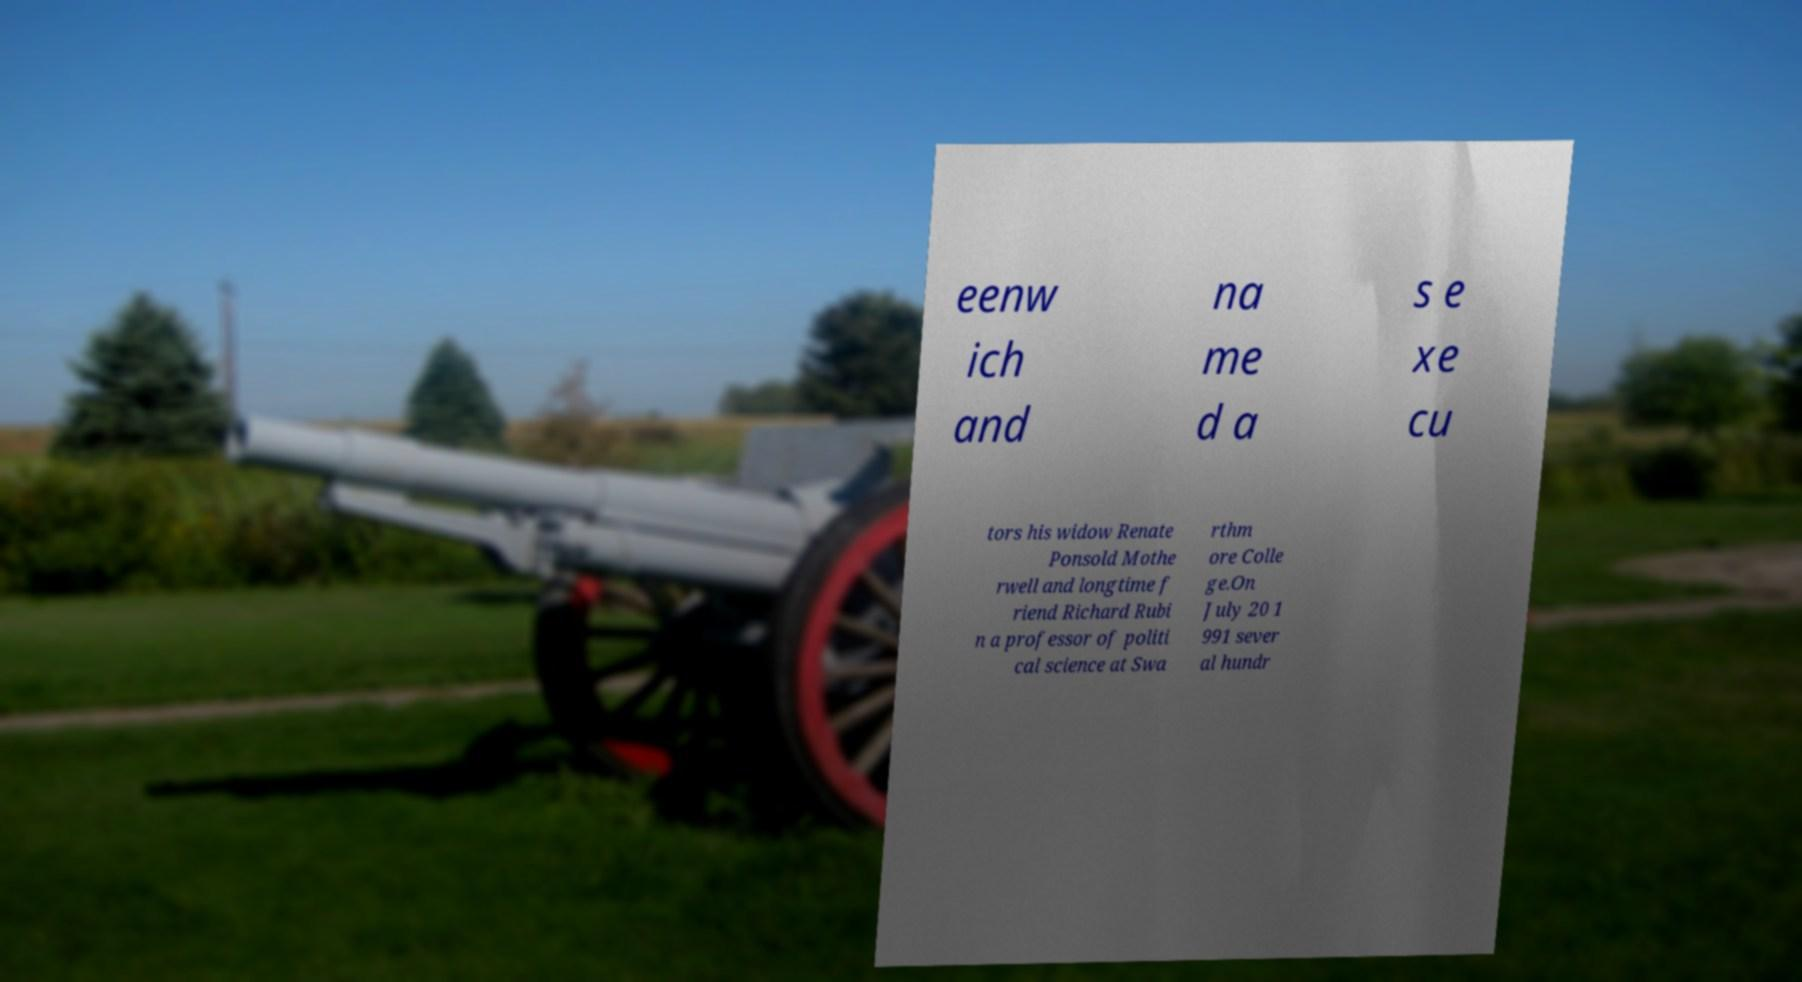There's text embedded in this image that I need extracted. Can you transcribe it verbatim? eenw ich and na me d a s e xe cu tors his widow Renate Ponsold Mothe rwell and longtime f riend Richard Rubi n a professor of politi cal science at Swa rthm ore Colle ge.On July 20 1 991 sever al hundr 